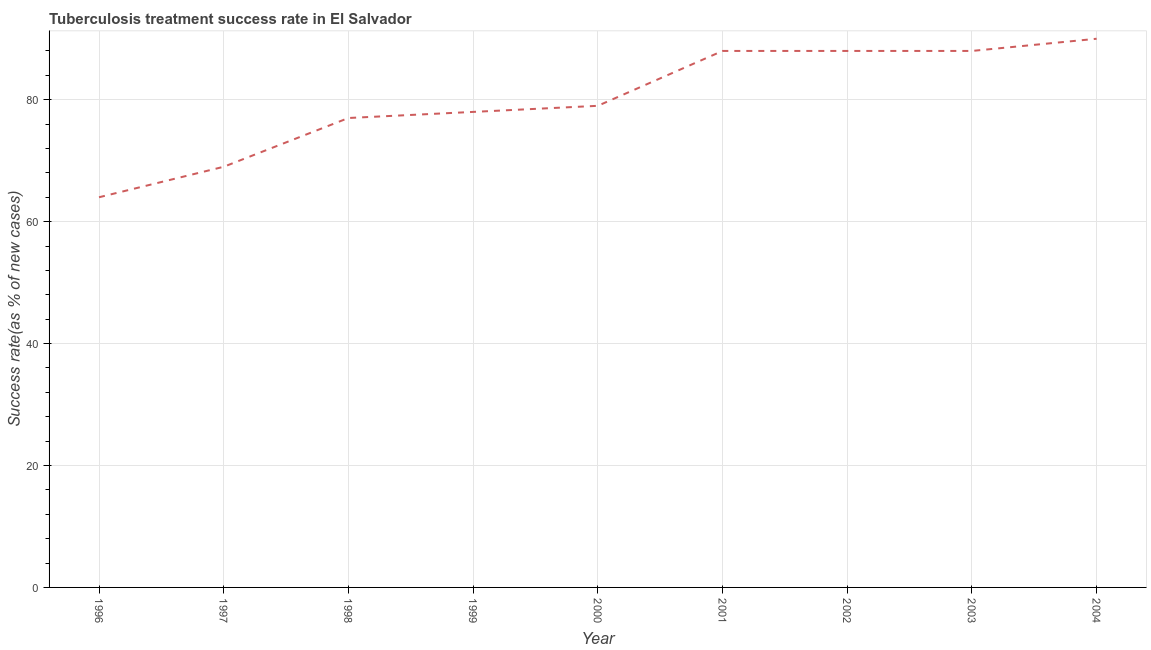What is the tuberculosis treatment success rate in 2001?
Ensure brevity in your answer.  88. Across all years, what is the maximum tuberculosis treatment success rate?
Offer a terse response. 90. Across all years, what is the minimum tuberculosis treatment success rate?
Keep it short and to the point. 64. In which year was the tuberculosis treatment success rate minimum?
Keep it short and to the point. 1996. What is the sum of the tuberculosis treatment success rate?
Your answer should be very brief. 721. What is the difference between the tuberculosis treatment success rate in 1996 and 2001?
Your answer should be very brief. -24. What is the average tuberculosis treatment success rate per year?
Provide a short and direct response. 80.11. What is the median tuberculosis treatment success rate?
Give a very brief answer. 79. What is the ratio of the tuberculosis treatment success rate in 1996 to that in 2002?
Make the answer very short. 0.73. Is the difference between the tuberculosis treatment success rate in 2003 and 2004 greater than the difference between any two years?
Your answer should be very brief. No. What is the difference between the highest and the second highest tuberculosis treatment success rate?
Provide a short and direct response. 2. Is the sum of the tuberculosis treatment success rate in 1996 and 2002 greater than the maximum tuberculosis treatment success rate across all years?
Provide a succinct answer. Yes. What is the difference between the highest and the lowest tuberculosis treatment success rate?
Your answer should be compact. 26. In how many years, is the tuberculosis treatment success rate greater than the average tuberculosis treatment success rate taken over all years?
Provide a short and direct response. 4. How many lines are there?
Keep it short and to the point. 1. How many years are there in the graph?
Make the answer very short. 9. What is the title of the graph?
Offer a very short reply. Tuberculosis treatment success rate in El Salvador. What is the label or title of the X-axis?
Make the answer very short. Year. What is the label or title of the Y-axis?
Keep it short and to the point. Success rate(as % of new cases). What is the Success rate(as % of new cases) in 1996?
Ensure brevity in your answer.  64. What is the Success rate(as % of new cases) of 1999?
Offer a terse response. 78. What is the Success rate(as % of new cases) in 2000?
Provide a short and direct response. 79. What is the Success rate(as % of new cases) of 2002?
Your answer should be compact. 88. What is the difference between the Success rate(as % of new cases) in 1996 and 1999?
Provide a succinct answer. -14. What is the difference between the Success rate(as % of new cases) in 1996 and 2002?
Offer a very short reply. -24. What is the difference between the Success rate(as % of new cases) in 1996 and 2003?
Offer a terse response. -24. What is the difference between the Success rate(as % of new cases) in 1996 and 2004?
Offer a very short reply. -26. What is the difference between the Success rate(as % of new cases) in 1997 and 1999?
Keep it short and to the point. -9. What is the difference between the Success rate(as % of new cases) in 1998 and 2000?
Offer a terse response. -2. What is the difference between the Success rate(as % of new cases) in 1998 and 2002?
Your response must be concise. -11. What is the difference between the Success rate(as % of new cases) in 1999 and 2000?
Your response must be concise. -1. What is the difference between the Success rate(as % of new cases) in 1999 and 2002?
Make the answer very short. -10. What is the difference between the Success rate(as % of new cases) in 1999 and 2003?
Offer a terse response. -10. What is the difference between the Success rate(as % of new cases) in 1999 and 2004?
Offer a terse response. -12. What is the difference between the Success rate(as % of new cases) in 2000 and 2002?
Your answer should be very brief. -9. What is the difference between the Success rate(as % of new cases) in 2000 and 2003?
Offer a terse response. -9. What is the difference between the Success rate(as % of new cases) in 2000 and 2004?
Give a very brief answer. -11. What is the difference between the Success rate(as % of new cases) in 2001 and 2003?
Offer a terse response. 0. What is the difference between the Success rate(as % of new cases) in 2001 and 2004?
Ensure brevity in your answer.  -2. What is the difference between the Success rate(as % of new cases) in 2002 and 2003?
Ensure brevity in your answer.  0. What is the ratio of the Success rate(as % of new cases) in 1996 to that in 1997?
Provide a short and direct response. 0.93. What is the ratio of the Success rate(as % of new cases) in 1996 to that in 1998?
Keep it short and to the point. 0.83. What is the ratio of the Success rate(as % of new cases) in 1996 to that in 1999?
Your response must be concise. 0.82. What is the ratio of the Success rate(as % of new cases) in 1996 to that in 2000?
Ensure brevity in your answer.  0.81. What is the ratio of the Success rate(as % of new cases) in 1996 to that in 2001?
Give a very brief answer. 0.73. What is the ratio of the Success rate(as % of new cases) in 1996 to that in 2002?
Your answer should be compact. 0.73. What is the ratio of the Success rate(as % of new cases) in 1996 to that in 2003?
Offer a terse response. 0.73. What is the ratio of the Success rate(as % of new cases) in 1996 to that in 2004?
Give a very brief answer. 0.71. What is the ratio of the Success rate(as % of new cases) in 1997 to that in 1998?
Ensure brevity in your answer.  0.9. What is the ratio of the Success rate(as % of new cases) in 1997 to that in 1999?
Ensure brevity in your answer.  0.89. What is the ratio of the Success rate(as % of new cases) in 1997 to that in 2000?
Make the answer very short. 0.87. What is the ratio of the Success rate(as % of new cases) in 1997 to that in 2001?
Provide a succinct answer. 0.78. What is the ratio of the Success rate(as % of new cases) in 1997 to that in 2002?
Your answer should be compact. 0.78. What is the ratio of the Success rate(as % of new cases) in 1997 to that in 2003?
Keep it short and to the point. 0.78. What is the ratio of the Success rate(as % of new cases) in 1997 to that in 2004?
Your response must be concise. 0.77. What is the ratio of the Success rate(as % of new cases) in 1998 to that in 1999?
Make the answer very short. 0.99. What is the ratio of the Success rate(as % of new cases) in 1998 to that in 2000?
Your response must be concise. 0.97. What is the ratio of the Success rate(as % of new cases) in 1998 to that in 2002?
Your response must be concise. 0.88. What is the ratio of the Success rate(as % of new cases) in 1998 to that in 2003?
Offer a terse response. 0.88. What is the ratio of the Success rate(as % of new cases) in 1998 to that in 2004?
Keep it short and to the point. 0.86. What is the ratio of the Success rate(as % of new cases) in 1999 to that in 2001?
Offer a very short reply. 0.89. What is the ratio of the Success rate(as % of new cases) in 1999 to that in 2002?
Provide a succinct answer. 0.89. What is the ratio of the Success rate(as % of new cases) in 1999 to that in 2003?
Your answer should be compact. 0.89. What is the ratio of the Success rate(as % of new cases) in 1999 to that in 2004?
Ensure brevity in your answer.  0.87. What is the ratio of the Success rate(as % of new cases) in 2000 to that in 2001?
Your answer should be compact. 0.9. What is the ratio of the Success rate(as % of new cases) in 2000 to that in 2002?
Provide a short and direct response. 0.9. What is the ratio of the Success rate(as % of new cases) in 2000 to that in 2003?
Your answer should be very brief. 0.9. What is the ratio of the Success rate(as % of new cases) in 2000 to that in 2004?
Offer a terse response. 0.88. What is the ratio of the Success rate(as % of new cases) in 2001 to that in 2002?
Your answer should be very brief. 1. What is the ratio of the Success rate(as % of new cases) in 2001 to that in 2003?
Offer a terse response. 1. What is the ratio of the Success rate(as % of new cases) in 2002 to that in 2003?
Ensure brevity in your answer.  1. What is the ratio of the Success rate(as % of new cases) in 2002 to that in 2004?
Your response must be concise. 0.98. 